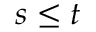<formula> <loc_0><loc_0><loc_500><loc_500>s \leq t</formula> 